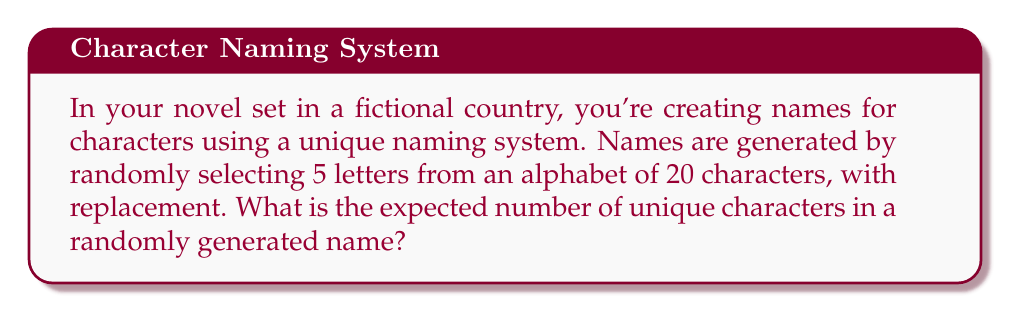Can you solve this math problem? Let's approach this step-by-step:

1) First, we need to recognize this as a problem involving the expected value of a random variable.

2) Let $X$ be the random variable representing the number of unique characters in a name.

3) For each character position, the probability of selecting a new (unique) character depends on how many unique characters have already been selected.

4) We can calculate the expected value using the linearity of expectation:

   $E[X] = E[X_1 + X_2 + X_3 + X_4 + X_5]$

   Where $X_i$ is an indicator variable that equals 1 if the $i$-th character is new, and 0 otherwise.

5) By linearity of expectation:

   $E[X] = E[X_1] + E[X_2] + E[X_3] + E[X_4] + E[X_5]$

6) Now, let's calculate each $E[X_i]$:

   $E[X_1] = 1$ (the first character is always unique)
   
   $E[X_2] = \frac{19}{20}$ (probability of selecting a different character than the first)
   
   $E[X_3] = \frac{18}{20}$ (probability of selecting a character different from the first two)
   
   $E[X_4] = \frac{17}{20}$
   
   $E[X_5] = \frac{16}{20}$

7) Sum these expectations:

   $E[X] = 1 + \frac{19}{20} + \frac{18}{20} + \frac{17}{20} + \frac{16}{20}$

8) Simplify:

   $E[X] = \frac{20}{20} + \frac{19}{20} + \frac{18}{20} + \frac{17}{20} + \frac{16}{20} = \frac{90}{20} = 4.5$

Therefore, the expected number of unique characters in a randomly generated name is 4.5.
Answer: 4.5 